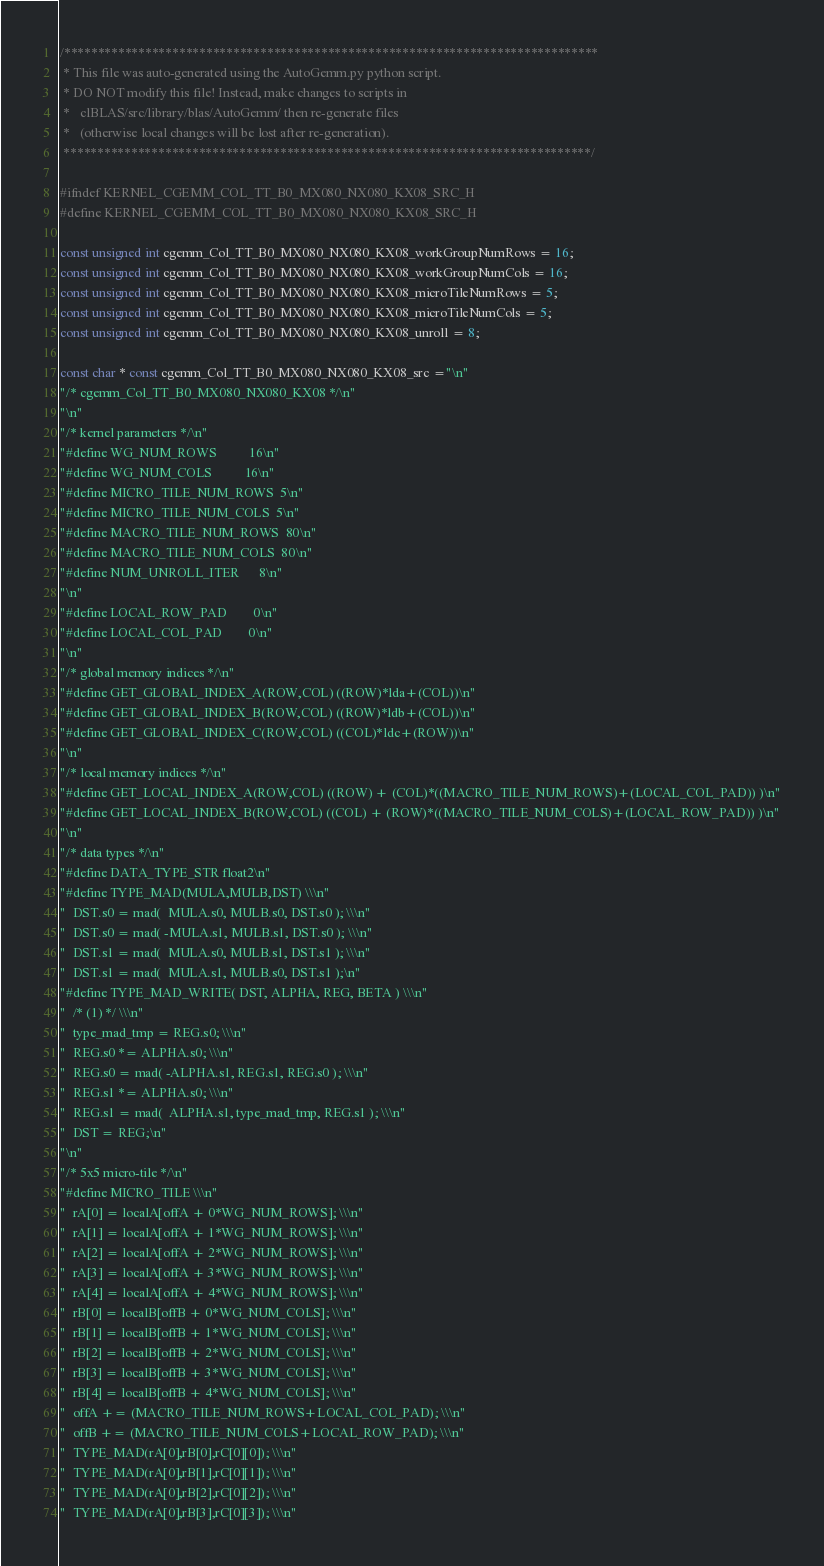<code> <loc_0><loc_0><loc_500><loc_500><_C++_>/*******************************************************************************
 * This file was auto-generated using the AutoGemm.py python script.
 * DO NOT modify this file! Instead, make changes to scripts in
 *   clBLAS/src/library/blas/AutoGemm/ then re-generate files
 *   (otherwise local changes will be lost after re-generation).
 ******************************************************************************/

#ifndef KERNEL_CGEMM_COL_TT_B0_MX080_NX080_KX08_SRC_H
#define KERNEL_CGEMM_COL_TT_B0_MX080_NX080_KX08_SRC_H

const unsigned int cgemm_Col_TT_B0_MX080_NX080_KX08_workGroupNumRows = 16;
const unsigned int cgemm_Col_TT_B0_MX080_NX080_KX08_workGroupNumCols = 16;
const unsigned int cgemm_Col_TT_B0_MX080_NX080_KX08_microTileNumRows = 5;
const unsigned int cgemm_Col_TT_B0_MX080_NX080_KX08_microTileNumCols = 5;
const unsigned int cgemm_Col_TT_B0_MX080_NX080_KX08_unroll = 8;

const char * const cgemm_Col_TT_B0_MX080_NX080_KX08_src ="\n"
"/* cgemm_Col_TT_B0_MX080_NX080_KX08 */\n"
"\n"
"/* kernel parameters */\n"
"#define WG_NUM_ROWS          16\n"
"#define WG_NUM_COLS          16\n"
"#define MICRO_TILE_NUM_ROWS  5\n"
"#define MICRO_TILE_NUM_COLS  5\n"
"#define MACRO_TILE_NUM_ROWS  80\n"
"#define MACRO_TILE_NUM_COLS  80\n"
"#define NUM_UNROLL_ITER      8\n"
"\n"
"#define LOCAL_ROW_PAD        0\n"
"#define LOCAL_COL_PAD        0\n"
"\n"
"/* global memory indices */\n"
"#define GET_GLOBAL_INDEX_A(ROW,COL) ((ROW)*lda+(COL))\n"
"#define GET_GLOBAL_INDEX_B(ROW,COL) ((ROW)*ldb+(COL))\n"
"#define GET_GLOBAL_INDEX_C(ROW,COL) ((COL)*ldc+(ROW))\n"
"\n"
"/* local memory indices */\n"
"#define GET_LOCAL_INDEX_A(ROW,COL) ((ROW) + (COL)*((MACRO_TILE_NUM_ROWS)+(LOCAL_COL_PAD)) )\n"
"#define GET_LOCAL_INDEX_B(ROW,COL) ((COL) + (ROW)*((MACRO_TILE_NUM_COLS)+(LOCAL_ROW_PAD)) )\n"
"\n"
"/* data types */\n"
"#define DATA_TYPE_STR float2\n"
"#define TYPE_MAD(MULA,MULB,DST) \\\n"
"  DST.s0 = mad(  MULA.s0, MULB.s0, DST.s0 ); \\\n"
"  DST.s0 = mad( -MULA.s1, MULB.s1, DST.s0 ); \\\n"
"  DST.s1 = mad(  MULA.s0, MULB.s1, DST.s1 ); \\\n"
"  DST.s1 = mad(  MULA.s1, MULB.s0, DST.s1 );\n"
"#define TYPE_MAD_WRITE( DST, ALPHA, REG, BETA ) \\\n"
"  /* (1) */ \\\n"
"  type_mad_tmp = REG.s0; \\\n"
"  REG.s0 *= ALPHA.s0; \\\n"
"  REG.s0 = mad( -ALPHA.s1, REG.s1, REG.s0 ); \\\n"
"  REG.s1 *= ALPHA.s0; \\\n"
"  REG.s1 = mad(  ALPHA.s1, type_mad_tmp, REG.s1 ); \\\n"
"  DST = REG;\n"
"\n"
"/* 5x5 micro-tile */\n"
"#define MICRO_TILE \\\n"
"  rA[0] = localA[offA + 0*WG_NUM_ROWS]; \\\n"
"  rA[1] = localA[offA + 1*WG_NUM_ROWS]; \\\n"
"  rA[2] = localA[offA + 2*WG_NUM_ROWS]; \\\n"
"  rA[3] = localA[offA + 3*WG_NUM_ROWS]; \\\n"
"  rA[4] = localA[offA + 4*WG_NUM_ROWS]; \\\n"
"  rB[0] = localB[offB + 0*WG_NUM_COLS]; \\\n"
"  rB[1] = localB[offB + 1*WG_NUM_COLS]; \\\n"
"  rB[2] = localB[offB + 2*WG_NUM_COLS]; \\\n"
"  rB[3] = localB[offB + 3*WG_NUM_COLS]; \\\n"
"  rB[4] = localB[offB + 4*WG_NUM_COLS]; \\\n"
"  offA += (MACRO_TILE_NUM_ROWS+LOCAL_COL_PAD); \\\n"
"  offB += (MACRO_TILE_NUM_COLS+LOCAL_ROW_PAD); \\\n"
"  TYPE_MAD(rA[0],rB[0],rC[0][0]); \\\n"
"  TYPE_MAD(rA[0],rB[1],rC[0][1]); \\\n"
"  TYPE_MAD(rA[0],rB[2],rC[0][2]); \\\n"
"  TYPE_MAD(rA[0],rB[3],rC[0][3]); \\\n"</code> 